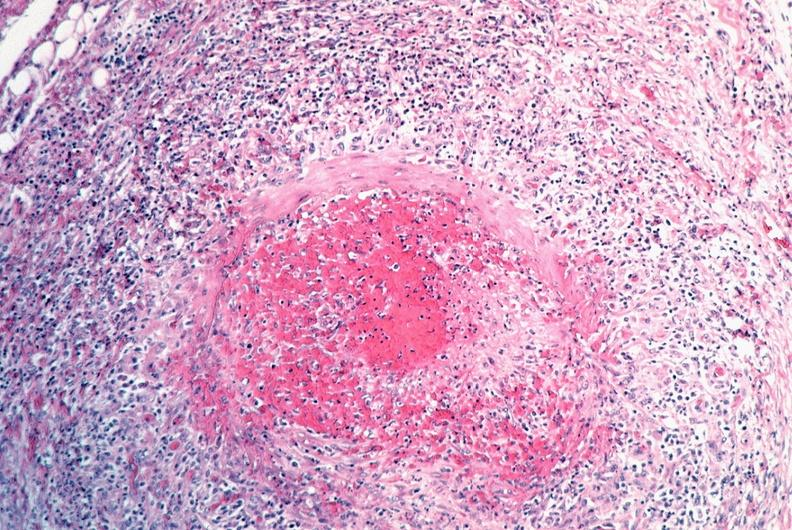does subdiaphragmatic abscess show vasculitis, polyarteritis nodosa?
Answer the question using a single word or phrase. No 